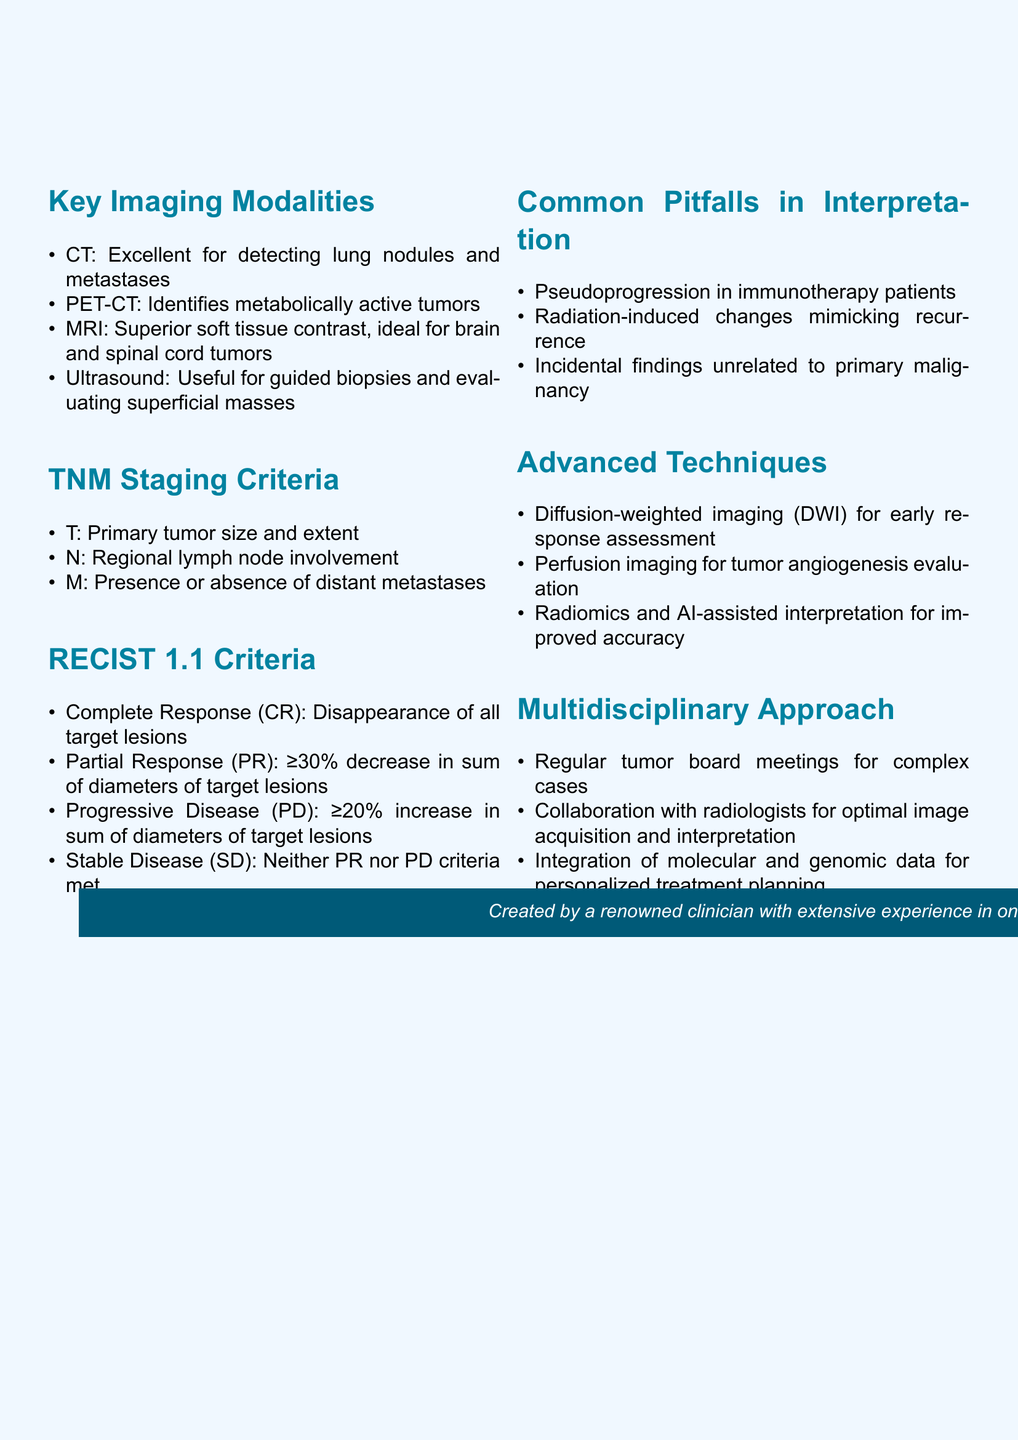What imaging modality is excellent for detecting lung nodules? The document states that CT (Computed Tomography) is excellent for detecting lung nodules and metastases.
Answer: CT What does the ‘T’ in TNM staging criteria represent? In the TNM staging criteria, 'T' represents the primary tumor size and extent.
Answer: Primary tumor size and extent What characterizes a Complete Response in RECIST 1.1 criteria? A Complete Response is characterized by the disappearance of all target lesions according to the RECIST 1.1 criteria.
Answer: Disappearance of all target lesions Name one common pitfall in interpretation noted in the document. The document lists pseudoprogression in immunotherapy patients as one common pitfall in interpretation.
Answer: Pseudoprogression What advanced technique is mentioned for early response assessment? Diffusion-weighted imaging (DWI) is noted as an advanced technique for early response assessment.
Answer: Diffusion-weighted imaging (DWI) How often should tumor board meetings occur according to the multidisciplinary approach? The document suggests regular tumor board meetings for complex cases.
Answer: Regular What imaging modality is ideal for brain and spinal cord tumors? MRI is mentioned as the imaging modality that is ideal for brain and spinal cord tumors.
Answer: MRI What is the percentage decrease that characterizes a Partial Response? A Partial Response is characterized by a decrease of 30% or more in the sum of diameters of target lesions.
Answer: 30% What type of imaging is used for evaluating tumor angiogenesis? Perfusion imaging is used for evaluating tumor angiogenesis as per the advanced techniques section.
Answer: Perfusion imaging 